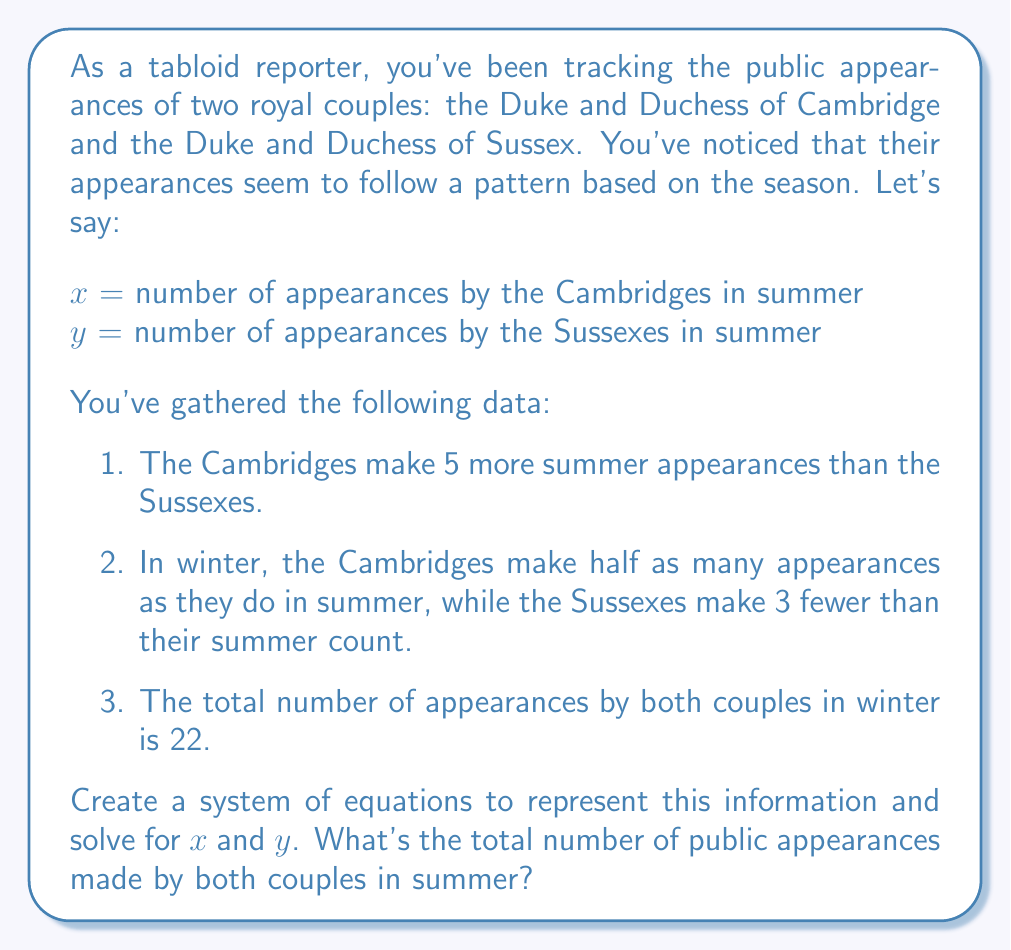Solve this math problem. Let's approach this step-by-step:

1) First, let's translate the given information into equations:

   a) The Cambridges make 5 more summer appearances than the Sussexes:
      $$x = y + 5$$

   b) In winter, the Cambridges make half as many appearances as they do in summer:
      Cambridges in winter = $\frac{x}{2}$

   c) In winter, the Sussexes make 3 fewer than their summer count:
      Sussexes in winter = $y - 3$

   d) The total number of appearances by both couples in winter is 22:
      $$\frac{x}{2} + (y - 3) = 22$$

2) Now we have a system of two equations:
   $$x = y + 5$$
   $$\frac{x}{2} + (y - 3) = 22$$

3) Let's substitute the first equation into the second:
   $$\frac{(y + 5)}{2} + (y - 3) = 22$$

4) Simplify:
   $$\frac{y}{2} + \frac{5}{2} + y - 3 = 22$$
   $$\frac{y}{2} + y = 22 - \frac{5}{2} + 3$$
   $$\frac{3y}{2} = \frac{47}{2}$$

5) Solve for $y$:
   $$y = \frac{47}{3} \approx 15.67$$

6) Since $y$ must be a whole number, we round down to 15 (as they can't make a partial appearance).

7) Now we can find $x$:
   $$x = 15 + 5 = 20$$

8) To get the total number of summer appearances, we add $x$ and $y$:
   $$20 + 15 = 35$$
Answer: The total number of public appearances made by both couples in summer is 35. 